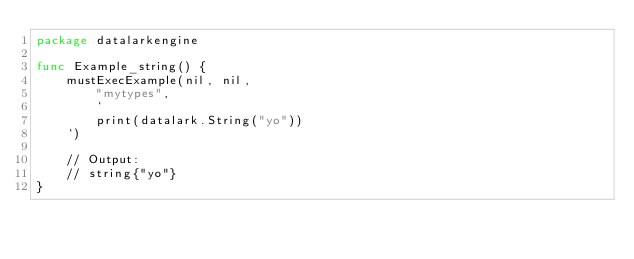<code> <loc_0><loc_0><loc_500><loc_500><_Go_>package datalarkengine

func Example_string() {
	mustExecExample(nil, nil,
		"mytypes",
		`
		print(datalark.String("yo"))
	`)

	// Output:
	// string{"yo"}
}
</code> 